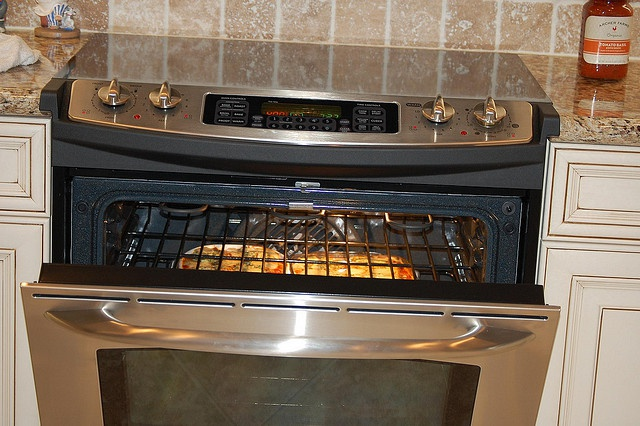Describe the objects in this image and their specific colors. I can see oven in brown, black, and gray tones and bottle in brown, maroon, and tan tones in this image. 